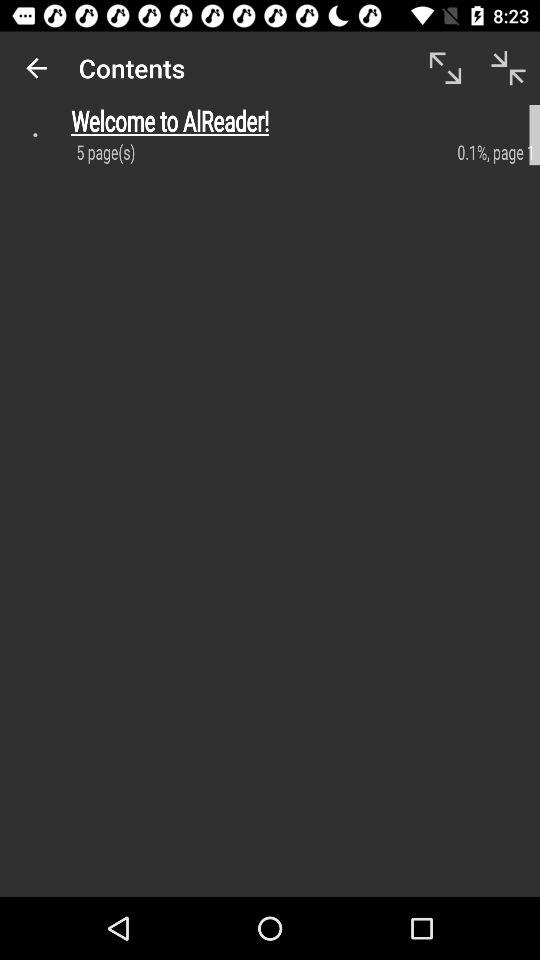How many pages are there in the document?
Answer the question using a single word or phrase. 5 